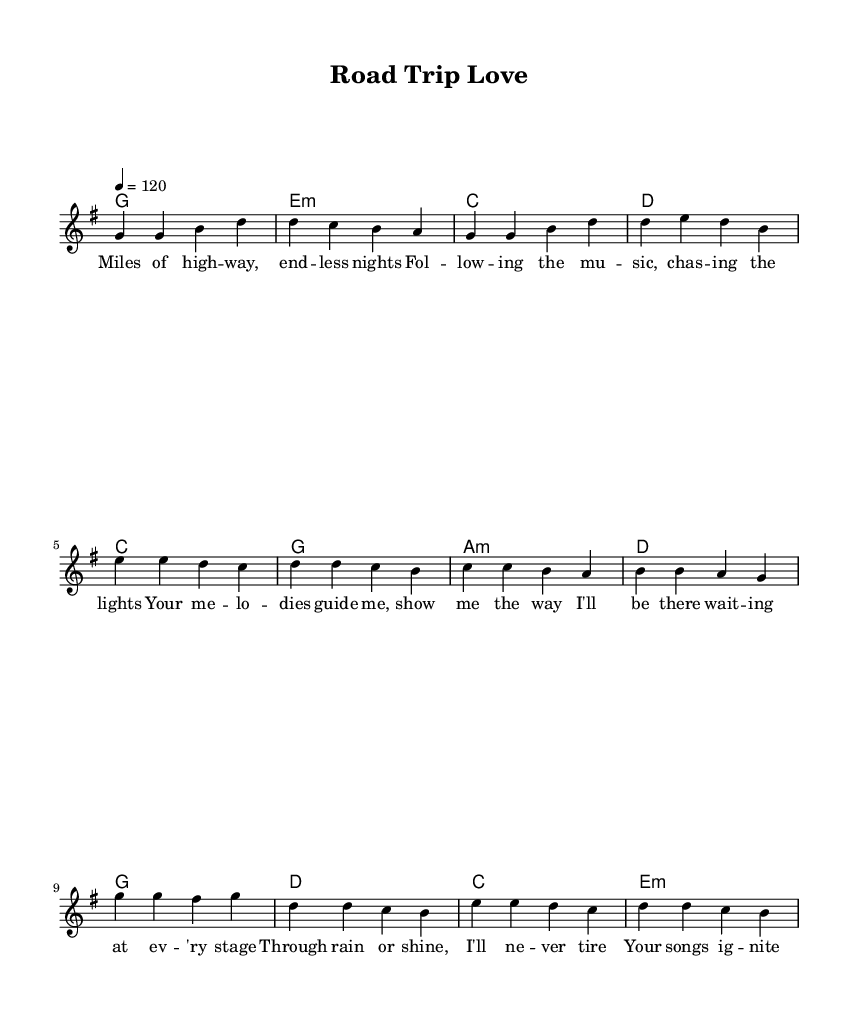What is the key signature of this music? The key signature is G major, which has one sharp (F#). This can be identified by looking at the key signature indicated at the beginning of the score.
Answer: G major What is the time signature of this music? The time signature of the music is 4/4. This can be seen right after the clef and key signature at the beginning of the score, indicating that there are four beats in each measure.
Answer: 4/4 What is the tempo marking in this music? The tempo marking indicates a speed of 120 beats per minute, as seen in the tempo indication ("4 = 120") at the start of the score.
Answer: 120 How many measures are there in the verse? The verse consists of four measures, which can be counted from the melody section of the score under the verse lyrics. Each line typically contains four measures, and there is one line for the verse.
Answer: 4 Which musical section contains the lyrics "Through rain or shine, I'll never tire"? These lyrics are found in the pre-chorus section of the song. By examining the lyric segments under the respective musical phrases, we can identify which lyrics belong to which section.
Answer: Pre-Chorus How many distinct sections does this piece of music have? The music has three distinct sections: verse, pre-chorus, and chorus. This can be determined by analyzing the structured layout of the lyrics and their corresponding melody and harmony sections.
Answer: 3 What is the chord used in the chorus? The chords stated in the chorus include G, D, C, and E minor, which can be identified by looking at the chords notated in the harmonies section matched with the lyrics.
Answer: G, D, C, E minor 